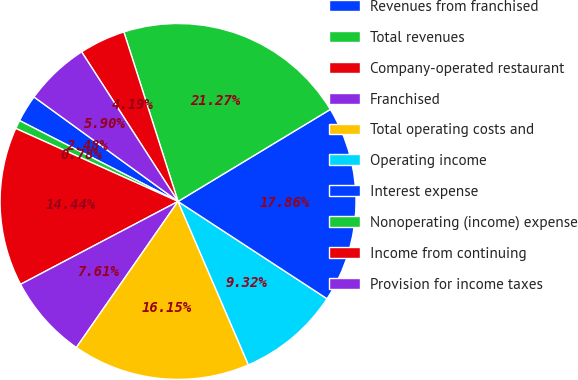Convert chart. <chart><loc_0><loc_0><loc_500><loc_500><pie_chart><fcel>Revenues from franchised<fcel>Total revenues<fcel>Company-operated restaurant<fcel>Franchised<fcel>Total operating costs and<fcel>Operating income<fcel>Interest expense<fcel>Nonoperating (income) expense<fcel>Income from continuing<fcel>Provision for income taxes<nl><fcel>2.48%<fcel>0.78%<fcel>14.44%<fcel>7.61%<fcel>16.15%<fcel>9.32%<fcel>17.86%<fcel>21.27%<fcel>4.19%<fcel>5.9%<nl></chart> 